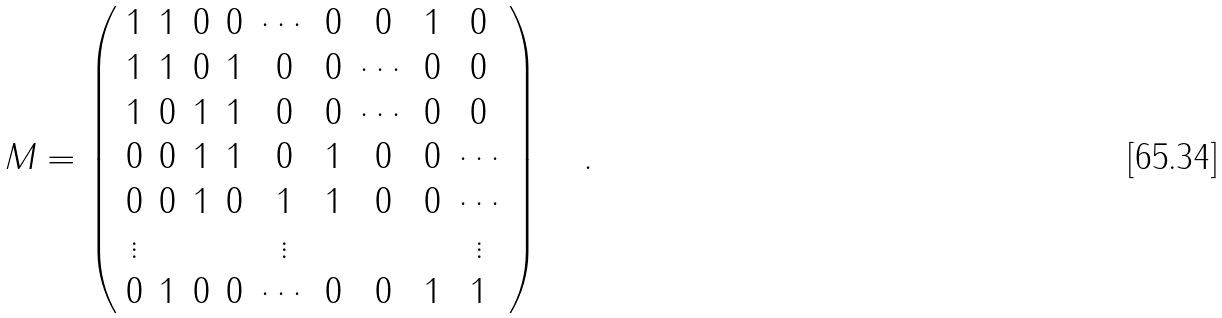Convert formula to latex. <formula><loc_0><loc_0><loc_500><loc_500>M = \left ( \begin{array} { c c c c c c c c c } 1 & 1 & 0 & 0 & \cdots & 0 & 0 & 1 & 0 \\ 1 & 1 & 0 & 1 & 0 & 0 & \cdots & 0 & 0 \\ 1 & 0 & 1 & 1 & 0 & 0 & \cdots & 0 & 0 \\ 0 & 0 & 1 & 1 & 0 & 1 & 0 & 0 & \cdots \\ 0 & 0 & 1 & 0 & 1 & 1 & 0 & 0 & \cdots \\ \vdots & & & & \vdots & & & & \vdots \\ 0 & 1 & 0 & 0 & \cdots & 0 & 0 & 1 & 1 \\ \end{array} \right ) \quad .</formula> 